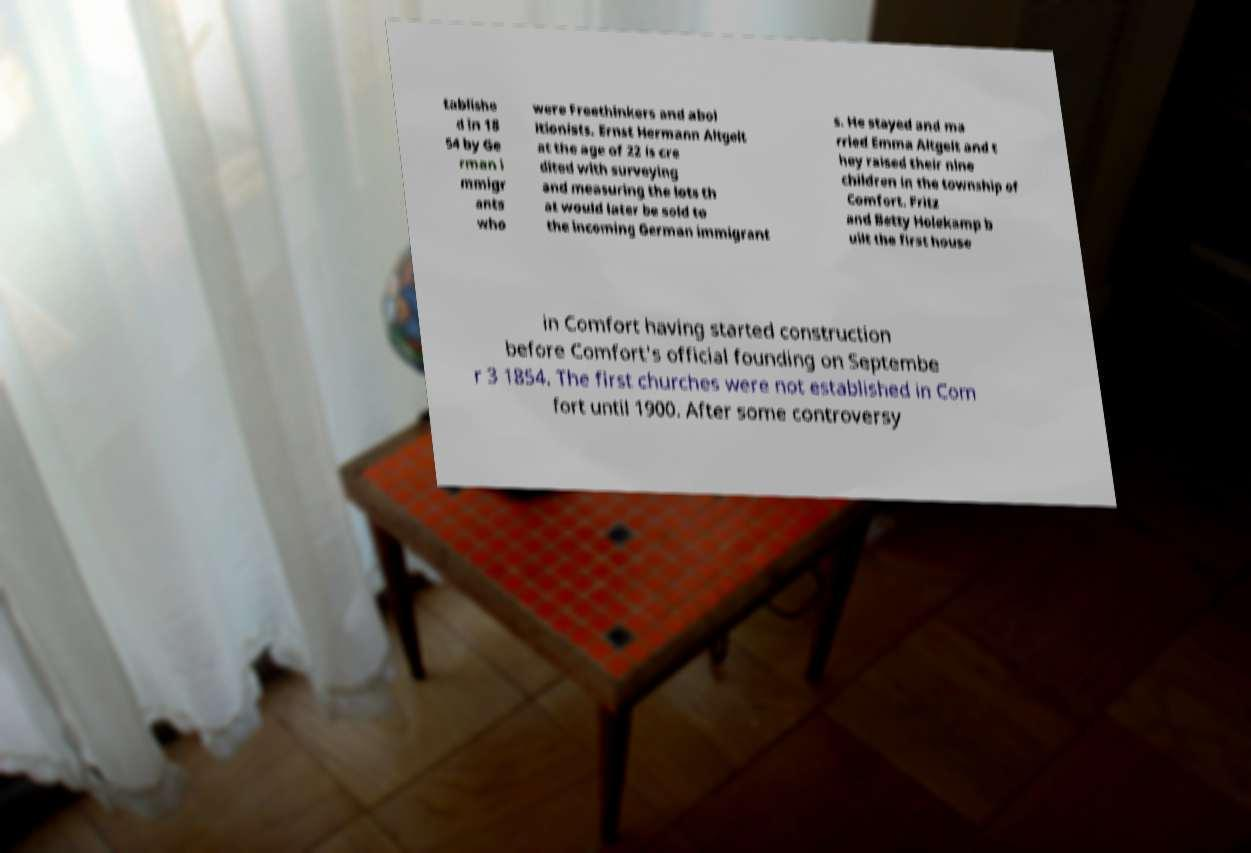Could you extract and type out the text from this image? tablishe d in 18 54 by Ge rman i mmigr ants who were Freethinkers and abol itionists. Ernst Hermann Altgelt at the age of 22 is cre dited with surveying and measuring the lots th at would later be sold to the incoming German immigrant s. He stayed and ma rried Emma Altgelt and t hey raised their nine children in the township of Comfort. Fritz and Betty Holekamp b uilt the first house in Comfort having started construction before Comfort's official founding on Septembe r 3 1854. The first churches were not established in Com fort until 1900. After some controversy 